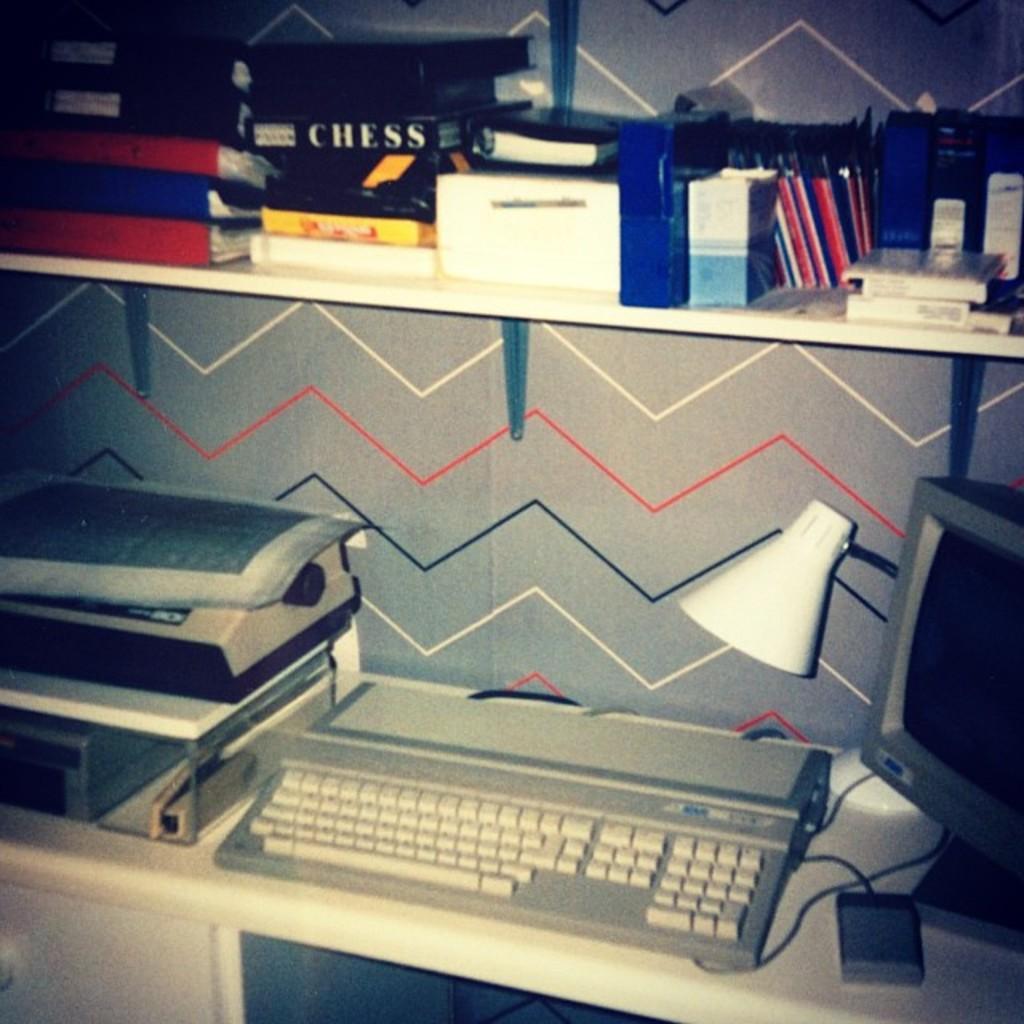How would you summarize this image in a sentence or two? In the center of the image we can see one table. On the table, we can see one monitor, machine, lamp, keyboard, link box, wire and a few other objects. Below the table, we can see a few other objects. In the background there is a wall. On the wall, we can see one shelf. On the shelf, we can see books, boxes and a few other objects. 